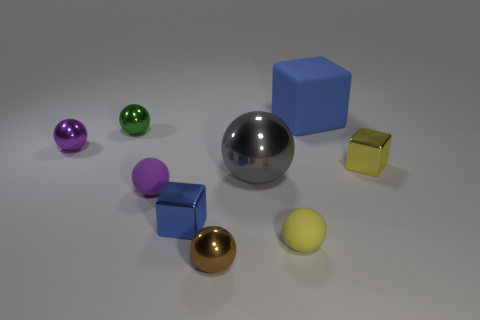How many blue cubes must be subtracted to get 1 blue cubes? 1 Subtract all tiny brown metal spheres. How many spheres are left? 5 Subtract all yellow cubes. How many cubes are left? 2 Subtract 5 balls. How many balls are left? 1 Subtract all balls. How many objects are left? 3 Subtract 0 red spheres. How many objects are left? 9 Subtract all brown balls. Subtract all purple cylinders. How many balls are left? 5 Subtract all yellow balls. How many blue cubes are left? 2 Subtract all small red metallic spheres. Subtract all large gray things. How many objects are left? 8 Add 1 purple objects. How many purple objects are left? 3 